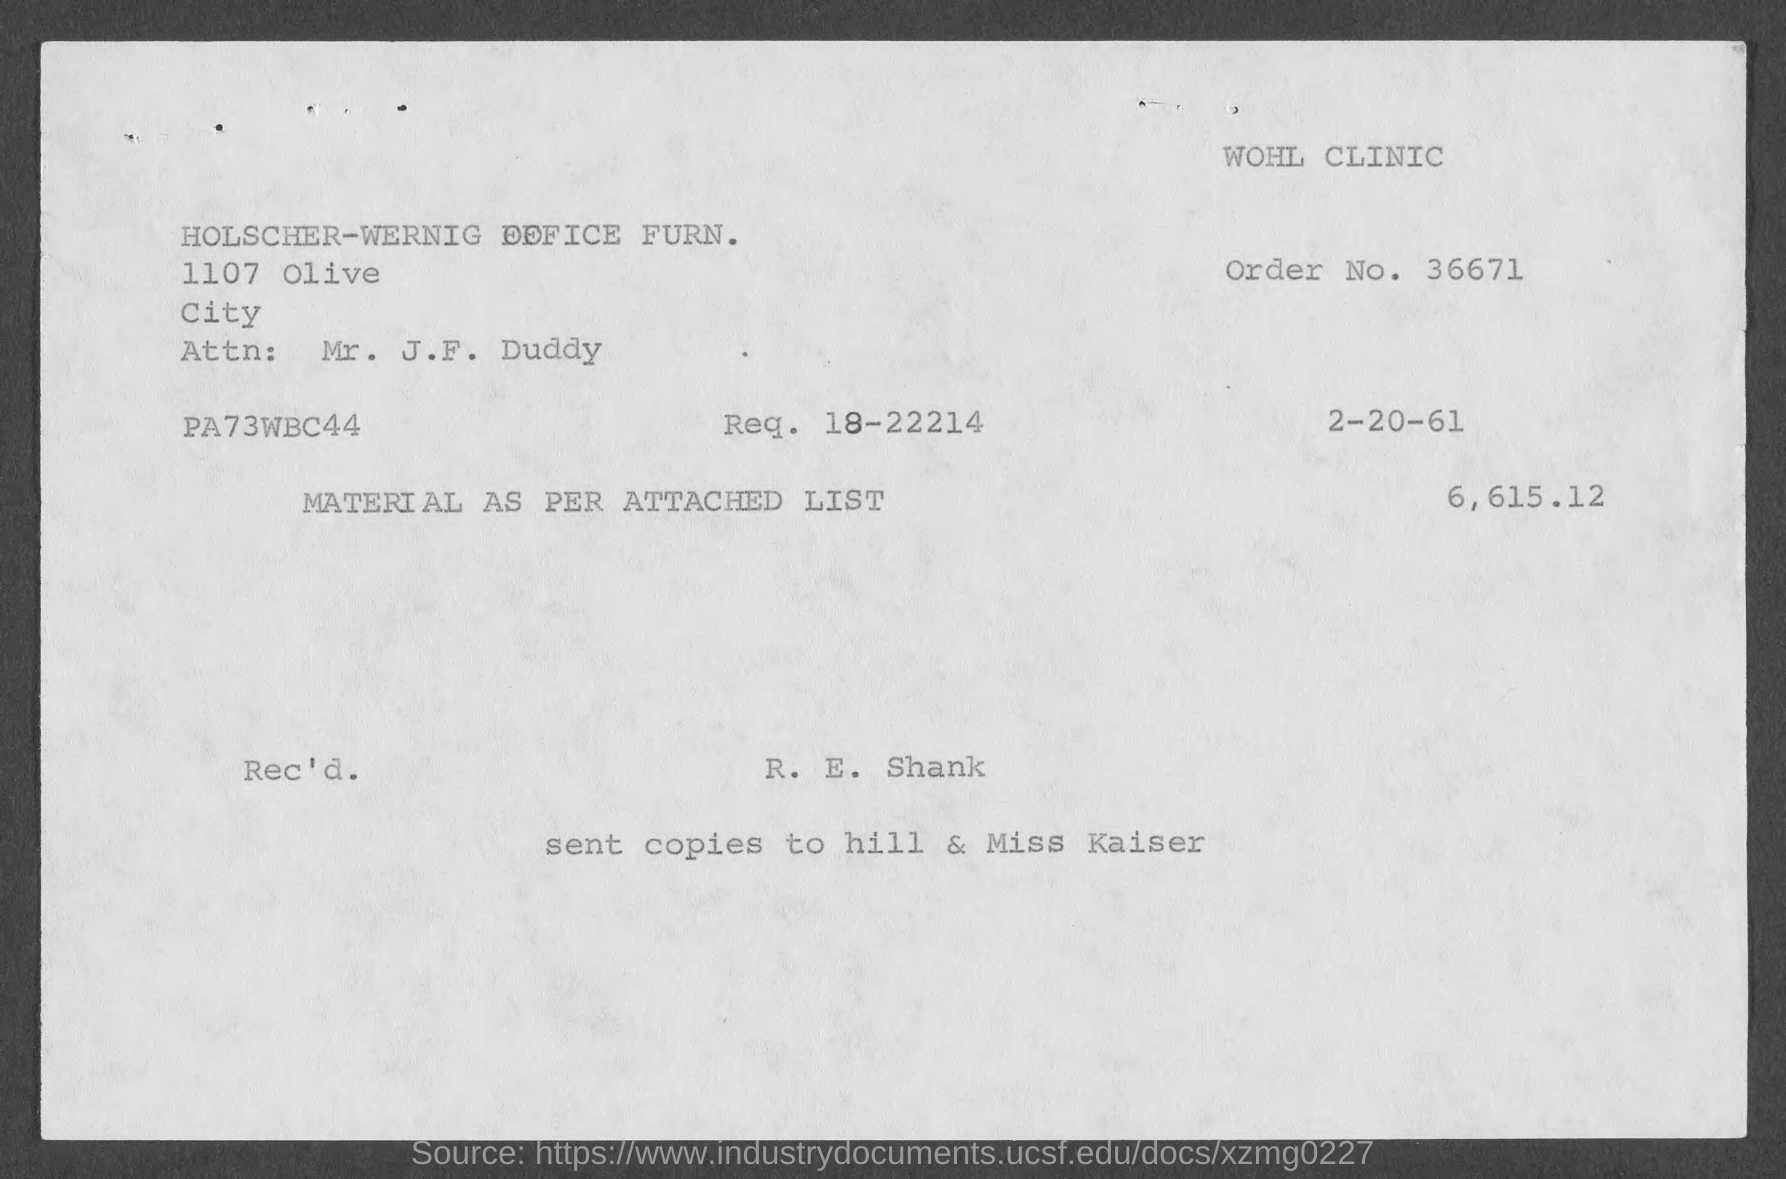What is the order no.?
Make the answer very short. 36671. What is the req. no?
Your answer should be compact. 18-22214. What is the attn. person name?
Provide a succinct answer. Mr. J. F. Duddy. What is the name of the clinic?
Offer a terse response. Wohl clinic. 